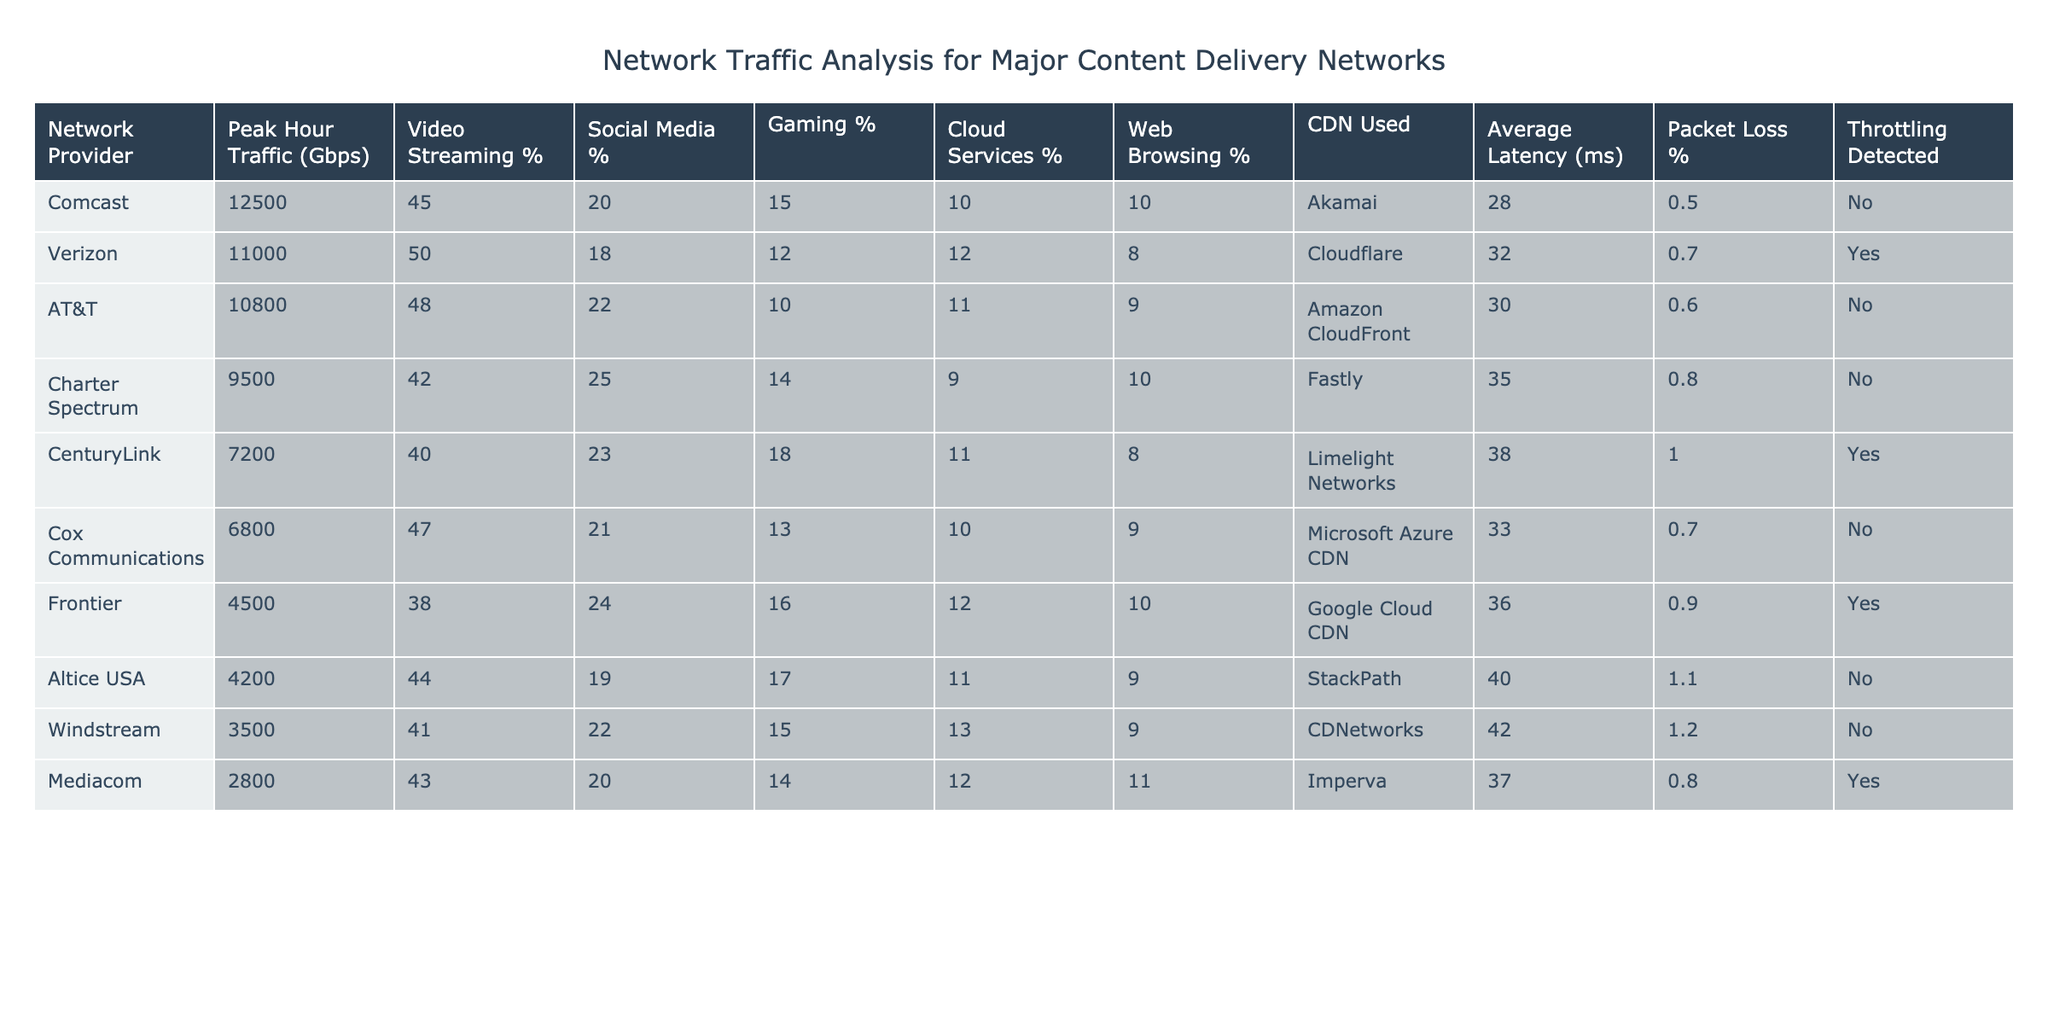What is the peak hour traffic for Comcast? The table lists Comcast's peak hour traffic as 12500 Gbps, which can be found in the "Peak Hour Traffic (Gbps)" column adjacent to the "Network Provider" row for Comcast.
Answer: 12500 Gbps Which network provider has the highest video streaming percentage? By examining the "Video Streaming %" column, it's clear that Verizon has the highest percentage at 50%, as compared to the other providers listed.
Answer: Verizon What is the average latency for the network providers using Akamai? Only Comcast uses Akamai as a CDN, which has an average latency of 28 ms. Since there’s only one provider, the average also remains 28 ms.
Answer: 28 ms How many network providers have throttling detected? By analyzing the "Throttling Detected" column, there are 3 entries marked "Yes," indicating that throttling has been detected for those providers.
Answer: 3 What is the difference in peak hour traffic between the highest and lowest network provider? The highest peak hour traffic is 12500 Gbps (Comcast) and the lowest is 2800 Gbps (Mediacom). The difference is calculated as 12500 - 2800 = 9700 Gbps.
Answer: 9700 Gbps Are cloud services the least utilized traffic type for any provider? By examining the "Cloud Services %" column, the provider with the least utilization rate for cloud services is Charter Spectrum, with 9%. This confirms that it is the lowest usage.
Answer: Yes What percentage of total peak hour traffic (for all providers combined) is typically used for video streaming? First, sum the peak hour traffic for all providers: 12500 + 11000 + 10800 + 9500 + 7200 + 6800 + 4500 + 4200 + 3500 + 2800 =  61100 Gbps in total. The total video streaming traffic is calculated as (12500 * 0.45) + (11000 * 0.50) + (10800 * 0.48) + (9500 * 0.42) + (7200 * 0.40) + (6800 * 0.47) + (4500 * 0.38) + (4200 * 0.44) + (3500 * 0.41) + (2800 * 0.43) = 26775 Gbps. Therefore, the percentage is (26775 / 61100) * 100 = 43.8%.
Answer: 43.8% Which CDN has the highest packet loss percentage and what is that percentage? Looking at the "Packet Loss %" column, the highest value listed is 1.2% for Windstream.
Answer: Windstream, 1.2% Is there any network provider that has both a high video streaming percentage and throttling detected? Reviewing the table, Verizon has a high video streaming percentage of 50% and has throttling detected. Thus, it is the only provider that matches both criteria.
Answer: Yes 